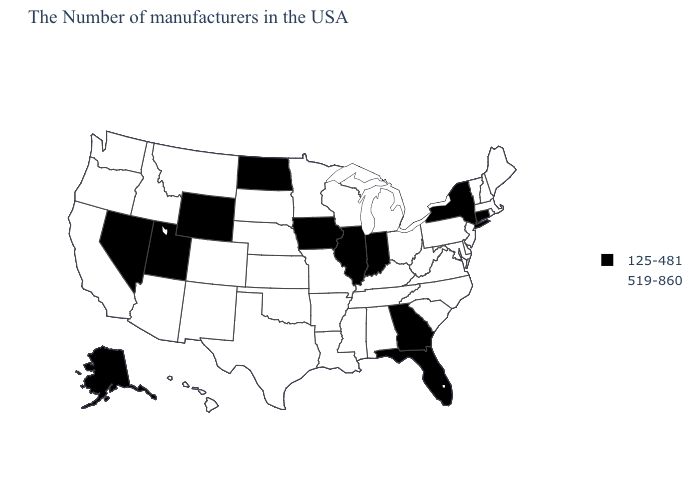What is the value of Ohio?
Give a very brief answer. 519-860. Among the states that border Tennessee , which have the highest value?
Short answer required. Virginia, North Carolina, Kentucky, Alabama, Mississippi, Missouri, Arkansas. Which states have the lowest value in the USA?
Concise answer only. Connecticut, New York, Florida, Georgia, Indiana, Illinois, Iowa, North Dakota, Wyoming, Utah, Nevada, Alaska. Which states have the highest value in the USA?
Quick response, please. Maine, Massachusetts, Rhode Island, New Hampshire, Vermont, New Jersey, Delaware, Maryland, Pennsylvania, Virginia, North Carolina, South Carolina, West Virginia, Ohio, Michigan, Kentucky, Alabama, Tennessee, Wisconsin, Mississippi, Louisiana, Missouri, Arkansas, Minnesota, Kansas, Nebraska, Oklahoma, Texas, South Dakota, Colorado, New Mexico, Montana, Arizona, Idaho, California, Washington, Oregon, Hawaii. Name the states that have a value in the range 125-481?
Be succinct. Connecticut, New York, Florida, Georgia, Indiana, Illinois, Iowa, North Dakota, Wyoming, Utah, Nevada, Alaska. Among the states that border Minnesota , which have the lowest value?
Answer briefly. Iowa, North Dakota. Which states have the highest value in the USA?
Keep it brief. Maine, Massachusetts, Rhode Island, New Hampshire, Vermont, New Jersey, Delaware, Maryland, Pennsylvania, Virginia, North Carolina, South Carolina, West Virginia, Ohio, Michigan, Kentucky, Alabama, Tennessee, Wisconsin, Mississippi, Louisiana, Missouri, Arkansas, Minnesota, Kansas, Nebraska, Oklahoma, Texas, South Dakota, Colorado, New Mexico, Montana, Arizona, Idaho, California, Washington, Oregon, Hawaii. What is the value of Iowa?
Answer briefly. 125-481. Name the states that have a value in the range 125-481?
Short answer required. Connecticut, New York, Florida, Georgia, Indiana, Illinois, Iowa, North Dakota, Wyoming, Utah, Nevada, Alaska. Does the map have missing data?
Give a very brief answer. No. Is the legend a continuous bar?
Quick response, please. No. Does Kentucky have the same value as Oklahoma?
Write a very short answer. Yes. Which states hav the highest value in the South?
Be succinct. Delaware, Maryland, Virginia, North Carolina, South Carolina, West Virginia, Kentucky, Alabama, Tennessee, Mississippi, Louisiana, Arkansas, Oklahoma, Texas. What is the value of South Carolina?
Give a very brief answer. 519-860. Which states have the lowest value in the Northeast?
Keep it brief. Connecticut, New York. 